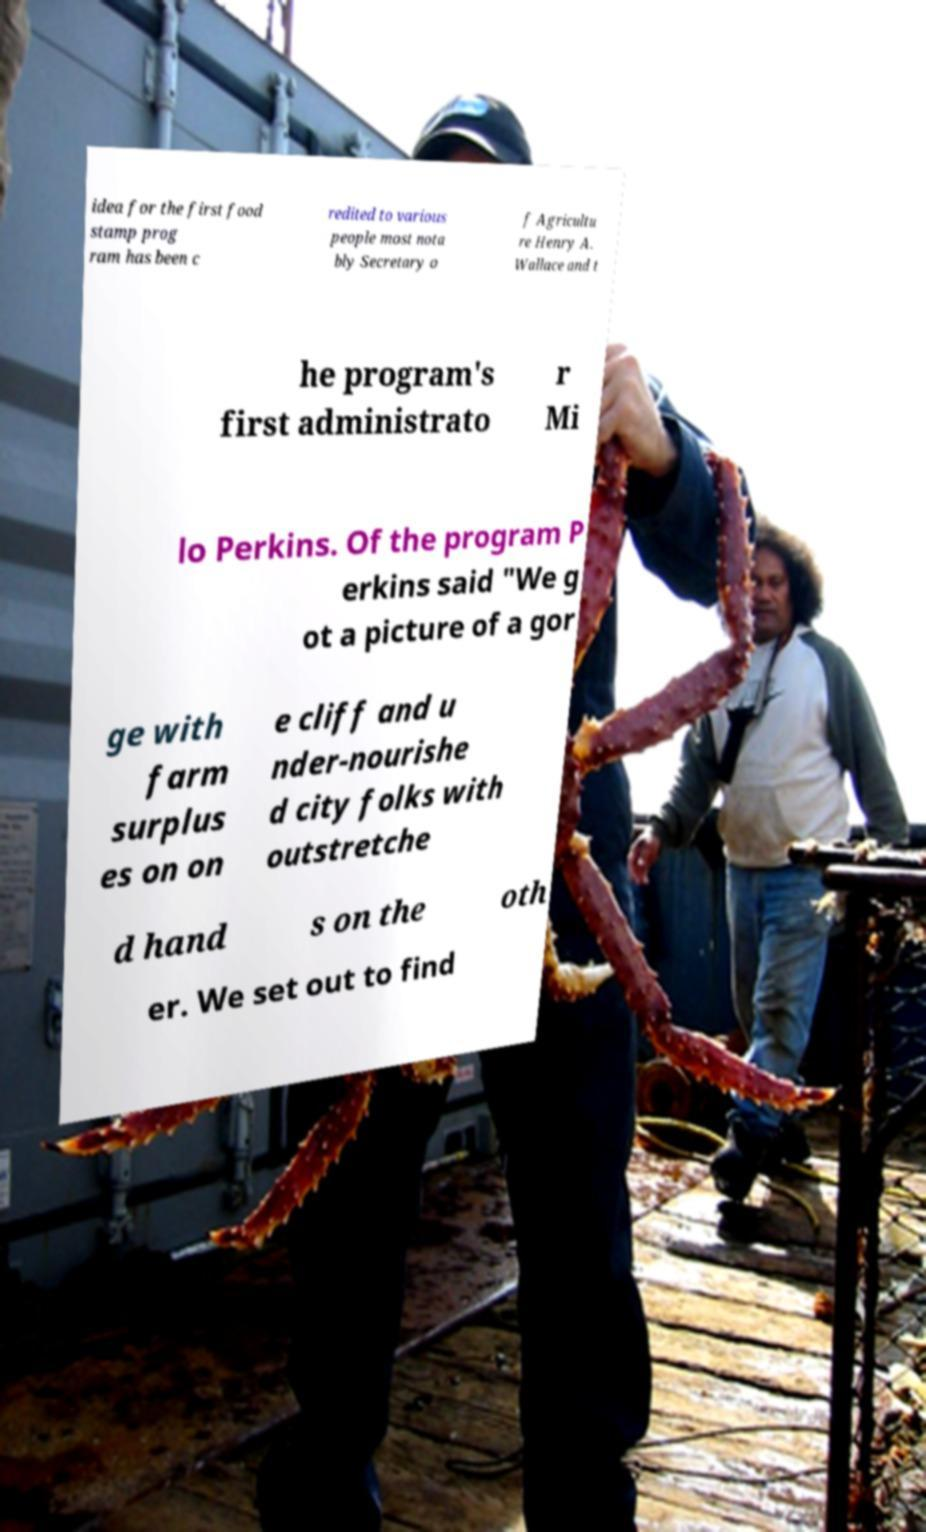Please identify and transcribe the text found in this image. idea for the first food stamp prog ram has been c redited to various people most nota bly Secretary o f Agricultu re Henry A. Wallace and t he program's first administrato r Mi lo Perkins. Of the program P erkins said "We g ot a picture of a gor ge with farm surplus es on on e cliff and u nder-nourishe d city folks with outstretche d hand s on the oth er. We set out to find 